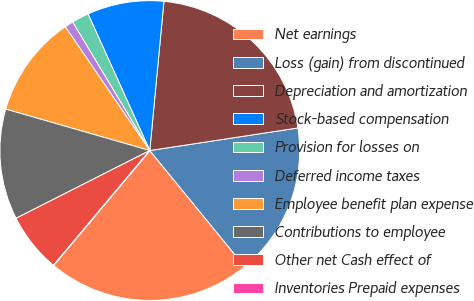Convert chart to OTSL. <chart><loc_0><loc_0><loc_500><loc_500><pie_chart><fcel>Net earnings<fcel>Loss (gain) from discontinued<fcel>Depreciation and amortization<fcel>Stock-based compensation<fcel>Provision for losses on<fcel>Deferred income taxes<fcel>Employee benefit plan expense<fcel>Contributions to employee<fcel>Other net Cash effect of<fcel>Inventories Prepaid expenses<nl><fcel>22.0%<fcel>16.5%<fcel>21.09%<fcel>8.26%<fcel>1.85%<fcel>0.93%<fcel>11.01%<fcel>11.92%<fcel>6.43%<fcel>0.01%<nl></chart> 